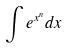Convert formula to latex. <formula><loc_0><loc_0><loc_500><loc_500>\int e ^ { x ^ { n } } d x</formula> 